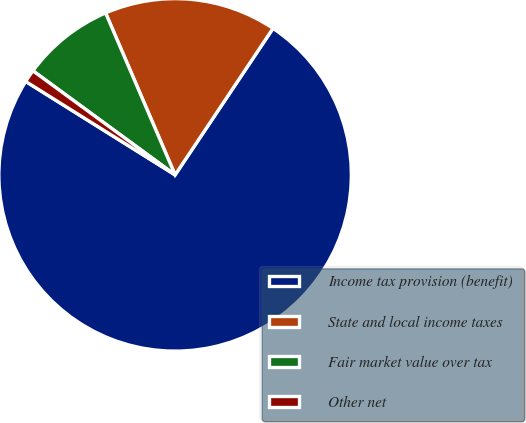Convert chart. <chart><loc_0><loc_0><loc_500><loc_500><pie_chart><fcel>Income tax provision (benefit)<fcel>State and local income taxes<fcel>Fair market value over tax<fcel>Other net<nl><fcel>74.52%<fcel>15.83%<fcel>8.49%<fcel>1.16%<nl></chart> 